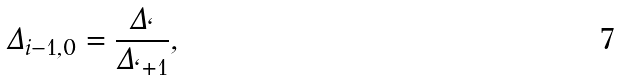<formula> <loc_0><loc_0><loc_500><loc_500>\Delta _ { i - 1 , 0 } = \frac { \Delta _ { \ell } } { \Delta _ { \ell + 1 } } ,</formula> 